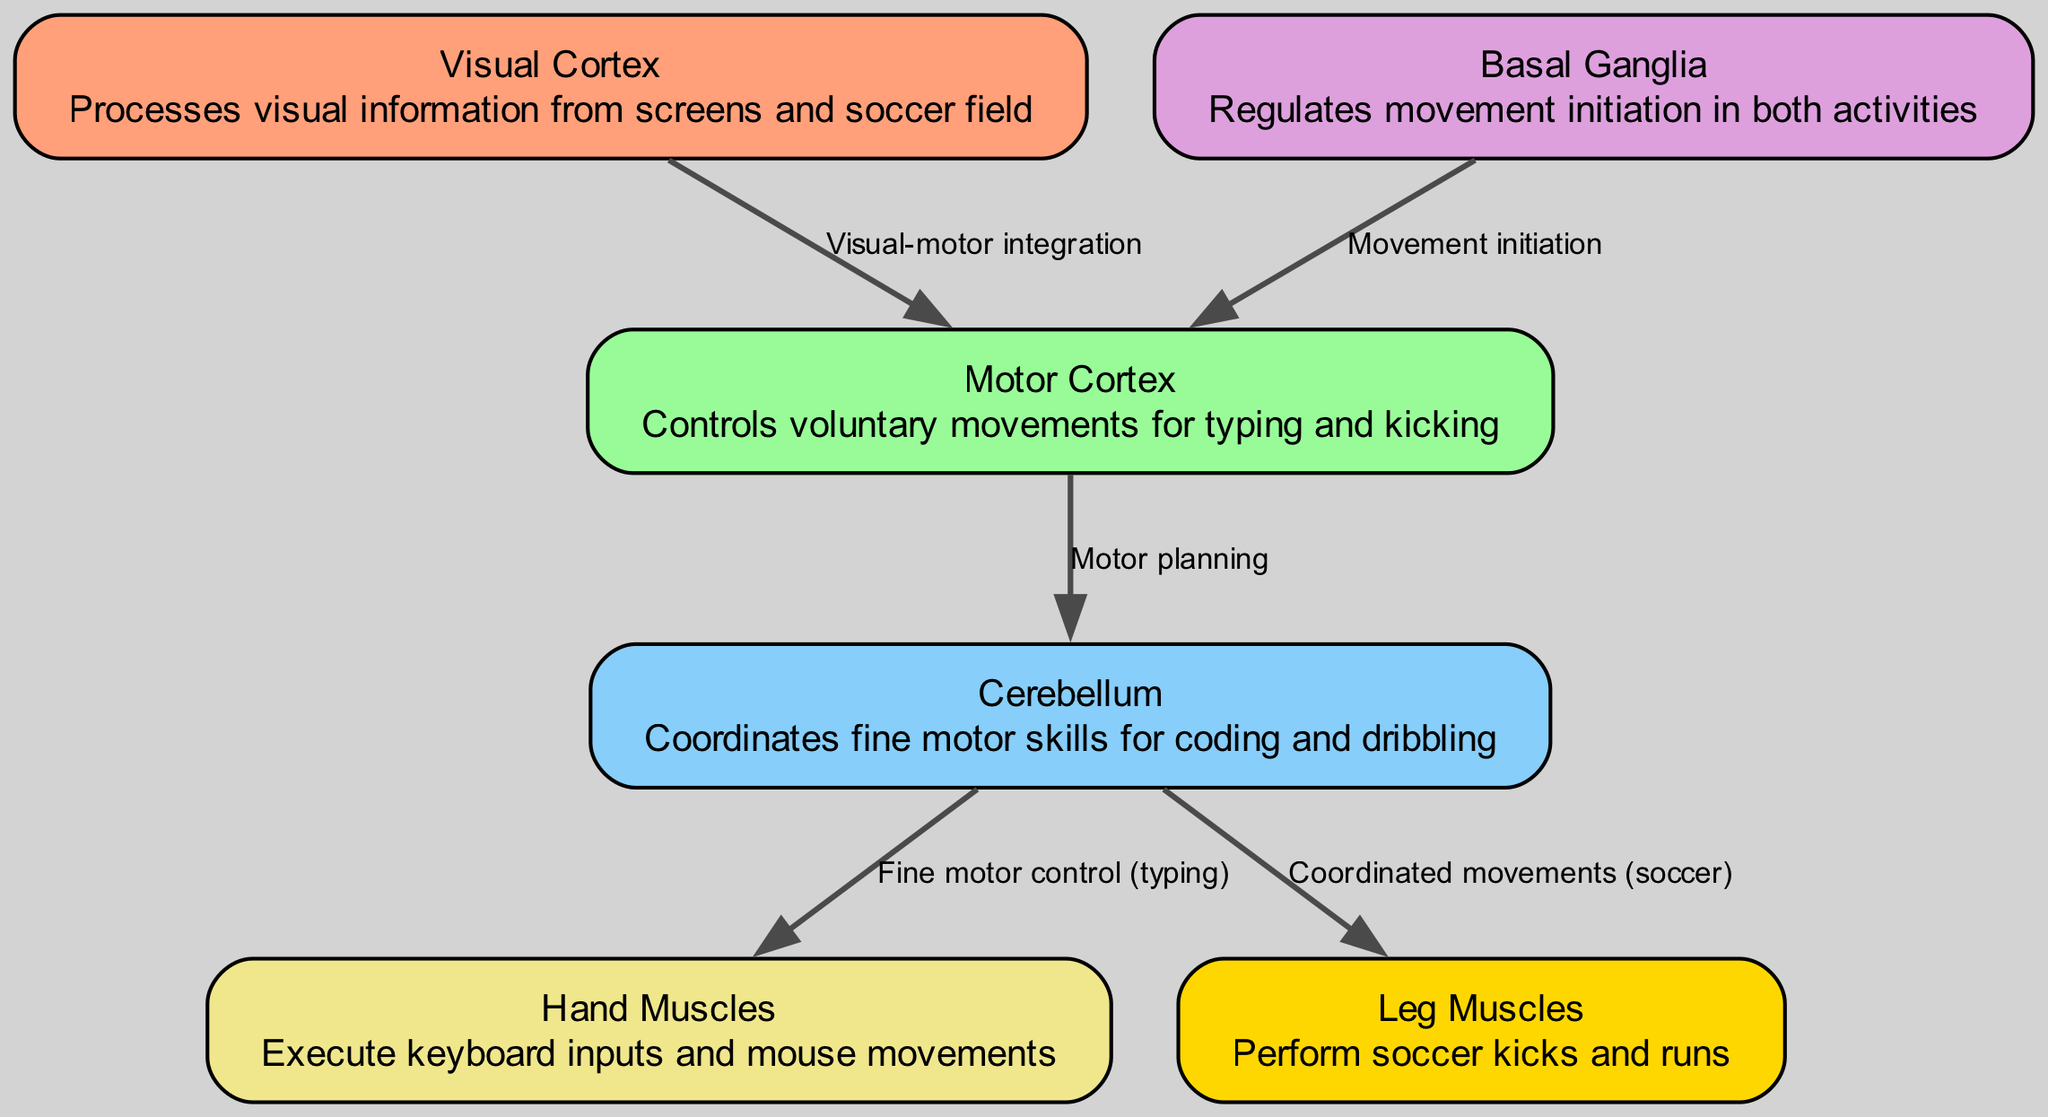What is the function of the visual cortex? The visual cortex processes visual information from screens and the soccer field, enabling the recognition of visual stimuli during programming and playing soccer.
Answer: Processes visual information How many nodes are in the diagram? By counting the distinct entities represented, there are a total of six nodes: visual cortex, motor cortex, cerebellum, basal ganglia, hand muscles, and leg muscles.
Answer: Six What connects the visual cortex to the motor cortex? The edge labelled "Visual-motor integration" connects the visual cortex to the motor cortex, indicating the relationship between visual perception and motor response.
Answer: Visual-motor integration Which part regulates movement initiation? The basal ganglia regulates movement initiation, as indicated by its direct connection to the motor cortex for starting movements in both activities.
Answer: Basal ganglia What type of control does the cerebellum provide for hand muscles? The cerebellum provides fine motor control for the hand muscles, specifically enabling precise typing actions.
Answer: Fine motor control How many edges are connecting nodes in the diagram? By counting the edges that connect different nodes, there are a total of five edges representing various interactions between the brain regions and muscle groups.
Answer: Five What relationship does the cerebellum have with leg muscles? The cerebellum is linked to leg muscles through the edge labelled "Coordinated movements (soccer)," indicating its role in coordinating movements relevant to soccer activities.
Answer: Coordinated movements Which node directly influences the motor cortex for initiating movement? The basal ganglia directly influences the motor cortex, as shown by the edge that specifies this role for starting both coding and soccer movements.
Answer: Basal ganglia 